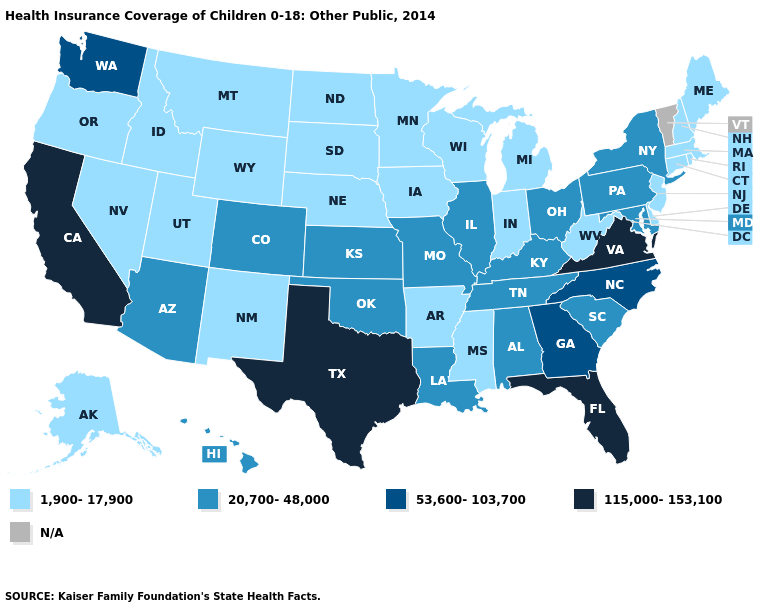What is the value of California?
Answer briefly. 115,000-153,100. Name the states that have a value in the range 20,700-48,000?
Keep it brief. Alabama, Arizona, Colorado, Hawaii, Illinois, Kansas, Kentucky, Louisiana, Maryland, Missouri, New York, Ohio, Oklahoma, Pennsylvania, South Carolina, Tennessee. What is the lowest value in states that border New Jersey?
Keep it brief. 1,900-17,900. Name the states that have a value in the range 53,600-103,700?
Keep it brief. Georgia, North Carolina, Washington. Does Colorado have the lowest value in the USA?
Write a very short answer. No. What is the lowest value in states that border Arkansas?
Give a very brief answer. 1,900-17,900. Does Washington have the highest value in the West?
Quick response, please. No. What is the value of Wyoming?
Short answer required. 1,900-17,900. Among the states that border Arkansas , which have the lowest value?
Write a very short answer. Mississippi. Does the first symbol in the legend represent the smallest category?
Short answer required. Yes. What is the value of Mississippi?
Concise answer only. 1,900-17,900. Among the states that border Maryland , does West Virginia have the lowest value?
Short answer required. Yes. Does the map have missing data?
Quick response, please. Yes. What is the highest value in the MidWest ?
Quick response, please. 20,700-48,000. 